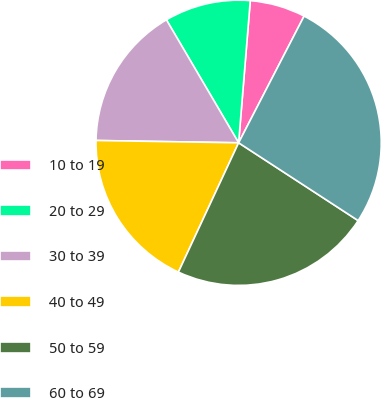Convert chart. <chart><loc_0><loc_0><loc_500><loc_500><pie_chart><fcel>10 to 19<fcel>20 to 29<fcel>30 to 39<fcel>40 to 49<fcel>50 to 59<fcel>60 to 69<nl><fcel>6.29%<fcel>9.75%<fcel>16.29%<fcel>18.32%<fcel>22.75%<fcel>26.59%<nl></chart> 